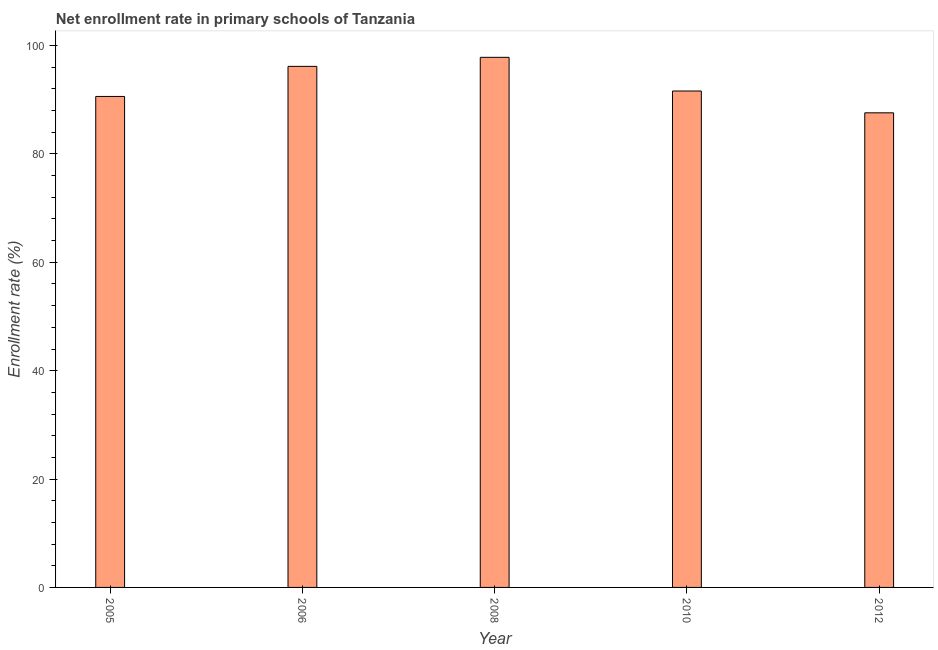Does the graph contain grids?
Give a very brief answer. No. What is the title of the graph?
Give a very brief answer. Net enrollment rate in primary schools of Tanzania. What is the label or title of the X-axis?
Offer a very short reply. Year. What is the label or title of the Y-axis?
Ensure brevity in your answer.  Enrollment rate (%). What is the net enrollment rate in primary schools in 2012?
Your answer should be compact. 87.59. Across all years, what is the maximum net enrollment rate in primary schools?
Your answer should be compact. 97.83. Across all years, what is the minimum net enrollment rate in primary schools?
Provide a short and direct response. 87.59. In which year was the net enrollment rate in primary schools minimum?
Offer a terse response. 2012. What is the sum of the net enrollment rate in primary schools?
Offer a terse response. 463.82. What is the difference between the net enrollment rate in primary schools in 2006 and 2010?
Your answer should be very brief. 4.55. What is the average net enrollment rate in primary schools per year?
Your answer should be compact. 92.76. What is the median net enrollment rate in primary schools?
Offer a terse response. 91.62. What is the ratio of the net enrollment rate in primary schools in 2010 to that in 2012?
Your response must be concise. 1.05. Is the difference between the net enrollment rate in primary schools in 2005 and 2012 greater than the difference between any two years?
Give a very brief answer. No. What is the difference between the highest and the second highest net enrollment rate in primary schools?
Your answer should be compact. 1.67. What is the difference between the highest and the lowest net enrollment rate in primary schools?
Provide a succinct answer. 10.24. In how many years, is the net enrollment rate in primary schools greater than the average net enrollment rate in primary schools taken over all years?
Offer a terse response. 2. Are all the bars in the graph horizontal?
Your answer should be very brief. No. How many years are there in the graph?
Your answer should be compact. 5. What is the Enrollment rate (%) in 2005?
Make the answer very short. 90.61. What is the Enrollment rate (%) in 2006?
Provide a succinct answer. 96.16. What is the Enrollment rate (%) in 2008?
Provide a short and direct response. 97.83. What is the Enrollment rate (%) in 2010?
Ensure brevity in your answer.  91.62. What is the Enrollment rate (%) in 2012?
Keep it short and to the point. 87.59. What is the difference between the Enrollment rate (%) in 2005 and 2006?
Ensure brevity in your answer.  -5.55. What is the difference between the Enrollment rate (%) in 2005 and 2008?
Your answer should be compact. -7.22. What is the difference between the Enrollment rate (%) in 2005 and 2010?
Keep it short and to the point. -1. What is the difference between the Enrollment rate (%) in 2005 and 2012?
Provide a short and direct response. 3.02. What is the difference between the Enrollment rate (%) in 2006 and 2008?
Offer a terse response. -1.67. What is the difference between the Enrollment rate (%) in 2006 and 2010?
Your answer should be very brief. 4.55. What is the difference between the Enrollment rate (%) in 2006 and 2012?
Keep it short and to the point. 8.57. What is the difference between the Enrollment rate (%) in 2008 and 2010?
Your answer should be very brief. 6.22. What is the difference between the Enrollment rate (%) in 2008 and 2012?
Offer a very short reply. 10.24. What is the difference between the Enrollment rate (%) in 2010 and 2012?
Offer a terse response. 4.03. What is the ratio of the Enrollment rate (%) in 2005 to that in 2006?
Your answer should be very brief. 0.94. What is the ratio of the Enrollment rate (%) in 2005 to that in 2008?
Offer a terse response. 0.93. What is the ratio of the Enrollment rate (%) in 2005 to that in 2012?
Your answer should be compact. 1.03. What is the ratio of the Enrollment rate (%) in 2006 to that in 2010?
Offer a very short reply. 1.05. What is the ratio of the Enrollment rate (%) in 2006 to that in 2012?
Make the answer very short. 1.1. What is the ratio of the Enrollment rate (%) in 2008 to that in 2010?
Offer a terse response. 1.07. What is the ratio of the Enrollment rate (%) in 2008 to that in 2012?
Provide a short and direct response. 1.12. What is the ratio of the Enrollment rate (%) in 2010 to that in 2012?
Your answer should be very brief. 1.05. 